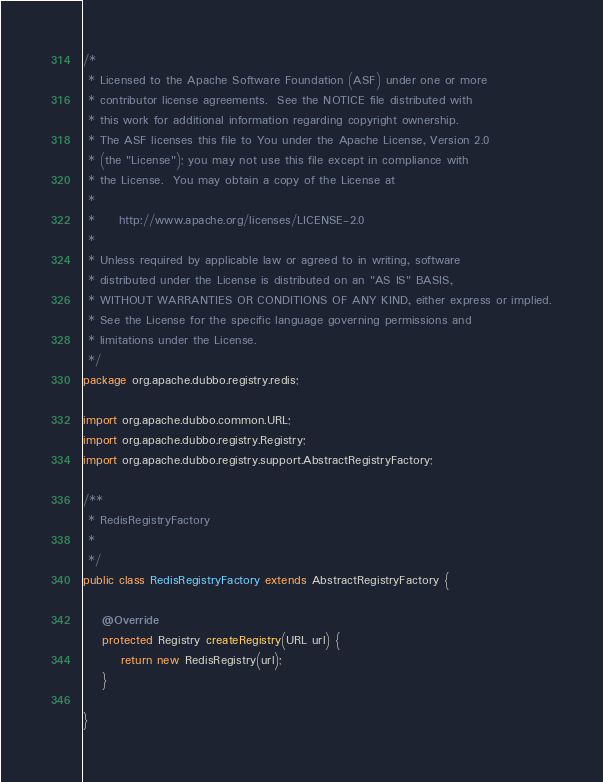<code> <loc_0><loc_0><loc_500><loc_500><_Java_>/*
 * Licensed to the Apache Software Foundation (ASF) under one or more
 * contributor license agreements.  See the NOTICE file distributed with
 * this work for additional information regarding copyright ownership.
 * The ASF licenses this file to You under the Apache License, Version 2.0
 * (the "License"); you may not use this file except in compliance with
 * the License.  You may obtain a copy of the License at
 *
 *     http://www.apache.org/licenses/LICENSE-2.0
 *
 * Unless required by applicable law or agreed to in writing, software
 * distributed under the License is distributed on an "AS IS" BASIS,
 * WITHOUT WARRANTIES OR CONDITIONS OF ANY KIND, either express or implied.
 * See the License for the specific language governing permissions and
 * limitations under the License.
 */
package org.apache.dubbo.registry.redis;

import org.apache.dubbo.common.URL;
import org.apache.dubbo.registry.Registry;
import org.apache.dubbo.registry.support.AbstractRegistryFactory;

/**
 * RedisRegistryFactory
 *
 */
public class RedisRegistryFactory extends AbstractRegistryFactory {

    @Override
    protected Registry createRegistry(URL url) {
        return new RedisRegistry(url);
    }

}
</code> 